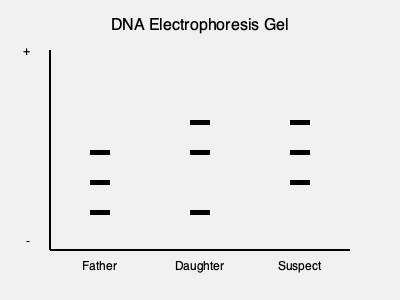Based on the DNA electrophoresis gel pattern shown, which of the following statements is most likely true regarding the relationship between the daughter and the suspect? To determine the relationship between the daughter and the suspect, we need to analyze the DNA electrophoresis gel pattern:

1. In DNA profiling, individuals who are closely related share more DNA bands in common.

2. Each person inherits half of their DNA from their father and half from their mother.

3. Comparing the daughter's lane to the father's lane:
   - They share 2 bands in common (at positions 150 and 210)
   - This is consistent with a parent-child relationship

4. Comparing the daughter's lane to the suspect's lane:
   - They share 2 bands in common (at positions 120 and 150)
   - This is also consistent with a parent-child relationship

5. The suspect's DNA profile is different from the known father's profile, but shares similarities with the daughter's profile.

6. Given that the daughter is searching for her true father's identity, and the suspect shares as many bands with her as the known father does, it's highly likely that the suspect could be her biological father.

Therefore, based on this DNA evidence, it's most likely that the suspect could be the daughter's biological father.
Answer: The suspect could be the daughter's biological father. 